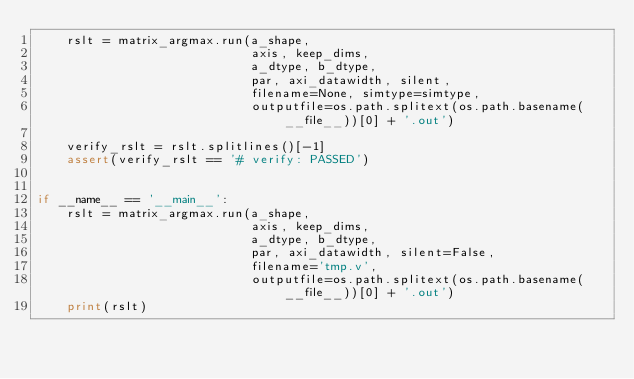<code> <loc_0><loc_0><loc_500><loc_500><_Python_>    rslt = matrix_argmax.run(a_shape,
                             axis, keep_dims,
                             a_dtype, b_dtype,
                             par, axi_datawidth, silent,
                             filename=None, simtype=simtype,
                             outputfile=os.path.splitext(os.path.basename(__file__))[0] + '.out')

    verify_rslt = rslt.splitlines()[-1]
    assert(verify_rslt == '# verify: PASSED')


if __name__ == '__main__':
    rslt = matrix_argmax.run(a_shape,
                             axis, keep_dims,
                             a_dtype, b_dtype,
                             par, axi_datawidth, silent=False,
                             filename='tmp.v',
                             outputfile=os.path.splitext(os.path.basename(__file__))[0] + '.out')
    print(rslt)
</code> 